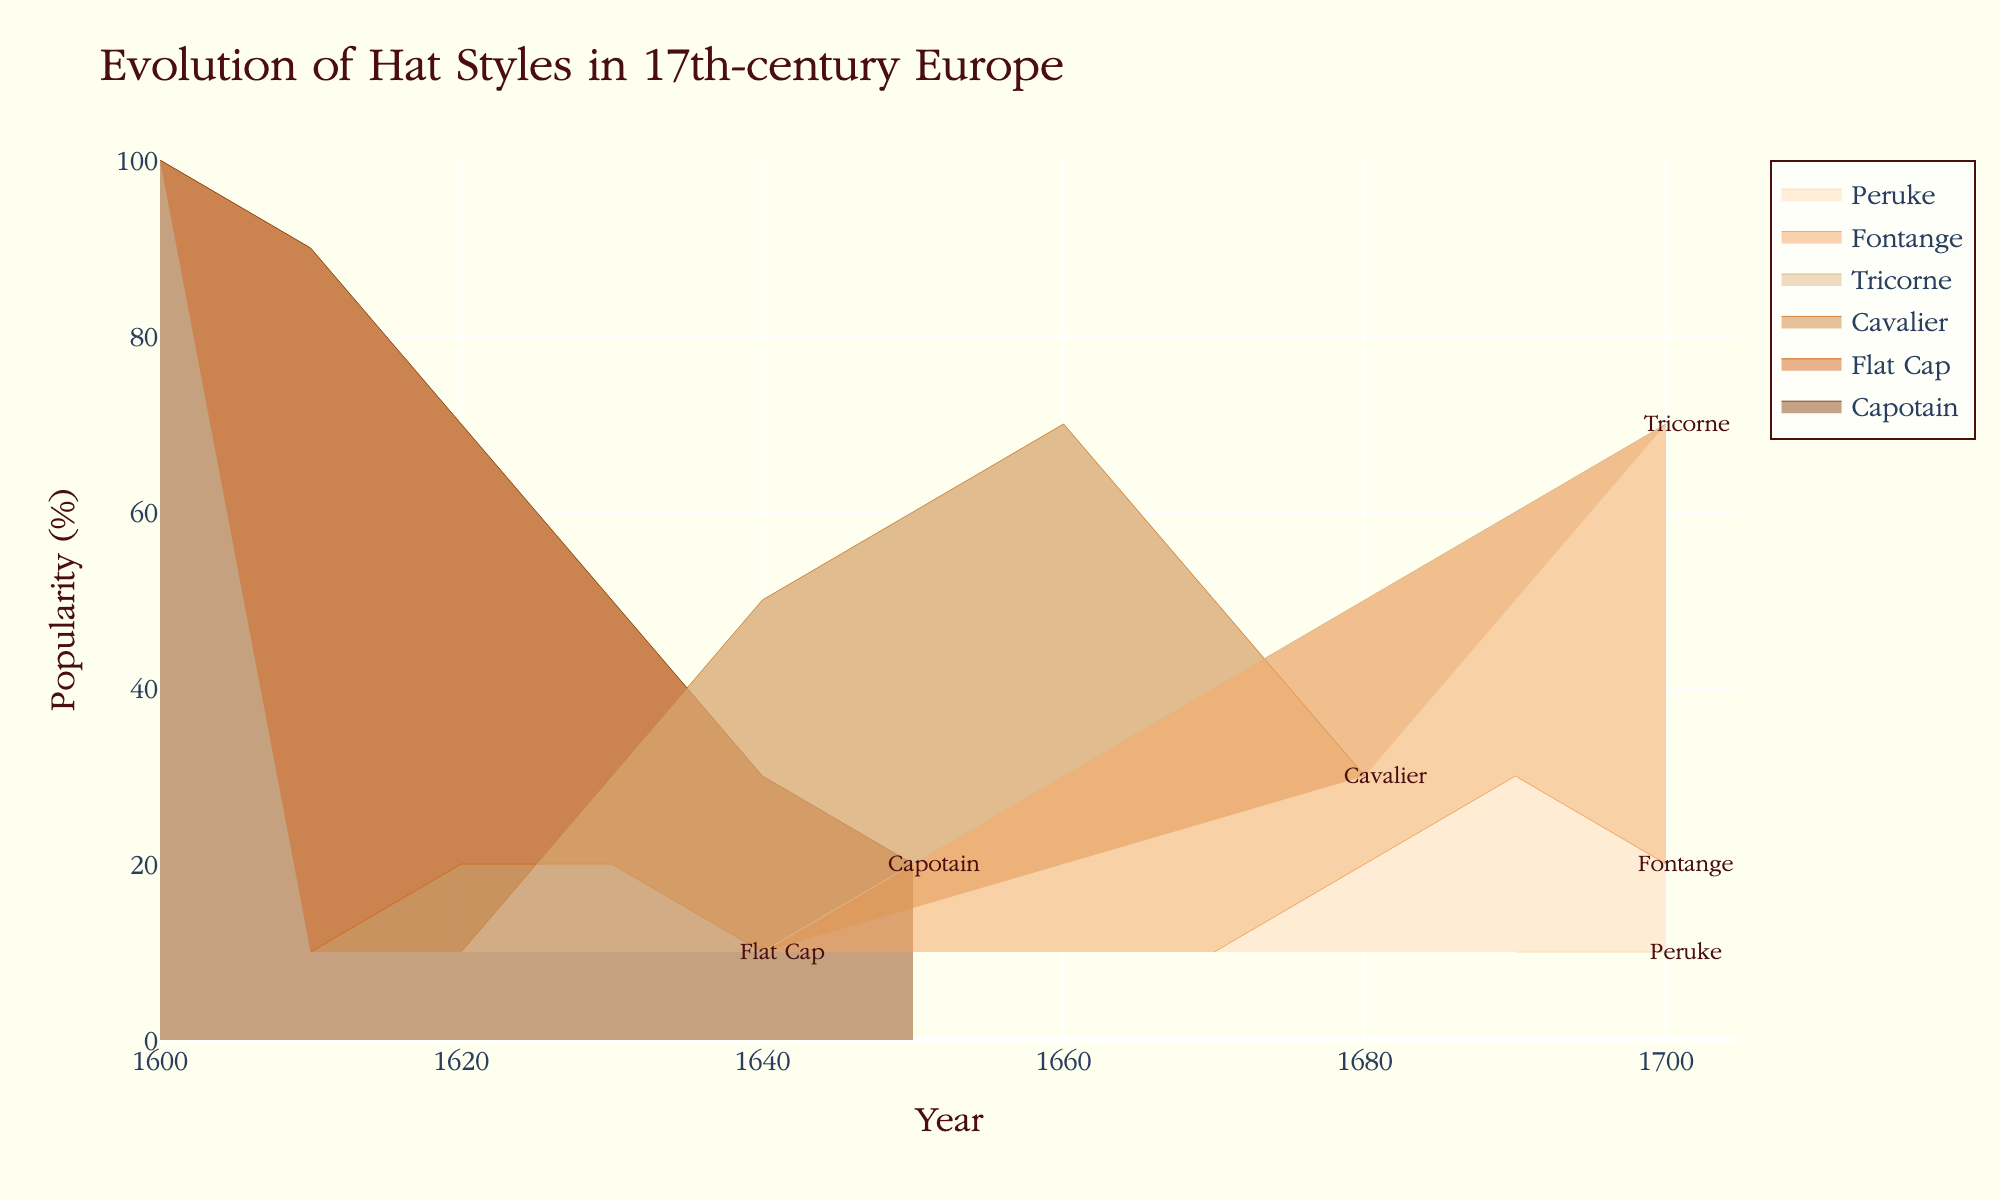How many hat styles are displayed on the chart? The chart shows six distinct hat styles over the 17th century. Look at the legend or the annotations to identify them.
Answer: Six Which hat style was most popular in 1600? According to the chart, the Capotain was at 100% popularity in 1600.
Answer: Capotain How does the popularity of the Cavalier hat style change from 1620 to 1670? Starting from 10% in 1620, the Cavalier's popularity rises to 30% in 1630, peaks at 60% in 1650, and then slightly declines to 50% in 1670.
Answer: It increases then slightly decreases What is the general trend of the Tricorne hat popularity from 1640 to 1700? The Tricorne hat's popularity begins at 10% in 1640, steadily rising to 70% by 1700.
Answer: Increasing Among the hat styles appearing in 1690, which had the lowest popularity? The Peruke was the least popular in 1690, with only 10% popularity.
Answer: Peruke During which decade did the Fontange hat style first appear, and what was its initial popularity? The Fontange first appeared in the 1670s with a popularity of 10%.
Answer: 1670s, 10% Which hat style experienced the greatest decline in popularity from the start to the end of the century? The Capotain experienced the greatest decline, starting at 100% in 1600 and dwindling to no visible representation by 1700.
Answer: Capotain Comparing the Flat Cap and the Tricorne, which had higher popularity and when was this? The Tricorne consistently had higher popularity than the Flat Cap, especially notable in 1700 with the Tricorne at 70% and the Flat Cap not visible on the chart.
Answer: Tricorne What hat style had a higher popularity percentage in 1680, Fontange or Cavalier? In 1680, the Fontange had a popularity of 20%, while the Cavalier had 30%, making the Cavalier more popular.
Answer: Cavalier When did the Peruke first appear and what was its trend in terms of popularity from that point? The Peruke first appeared in 1690 and maintained a steady popularity of 10% till 1700.
Answer: 1690, steady at 10% 